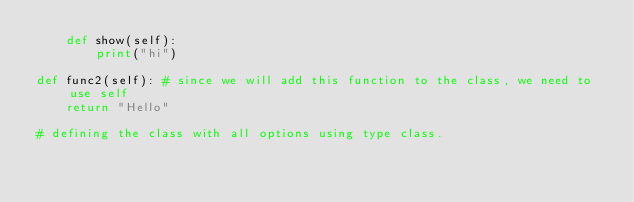Convert code to text. <code><loc_0><loc_0><loc_500><loc_500><_Python_>    def show(self):
        print("hi")

def func2(self): # since we will add this function to the class, we need to use self
    return "Hello"

# defining the class with all options using type class.</code> 